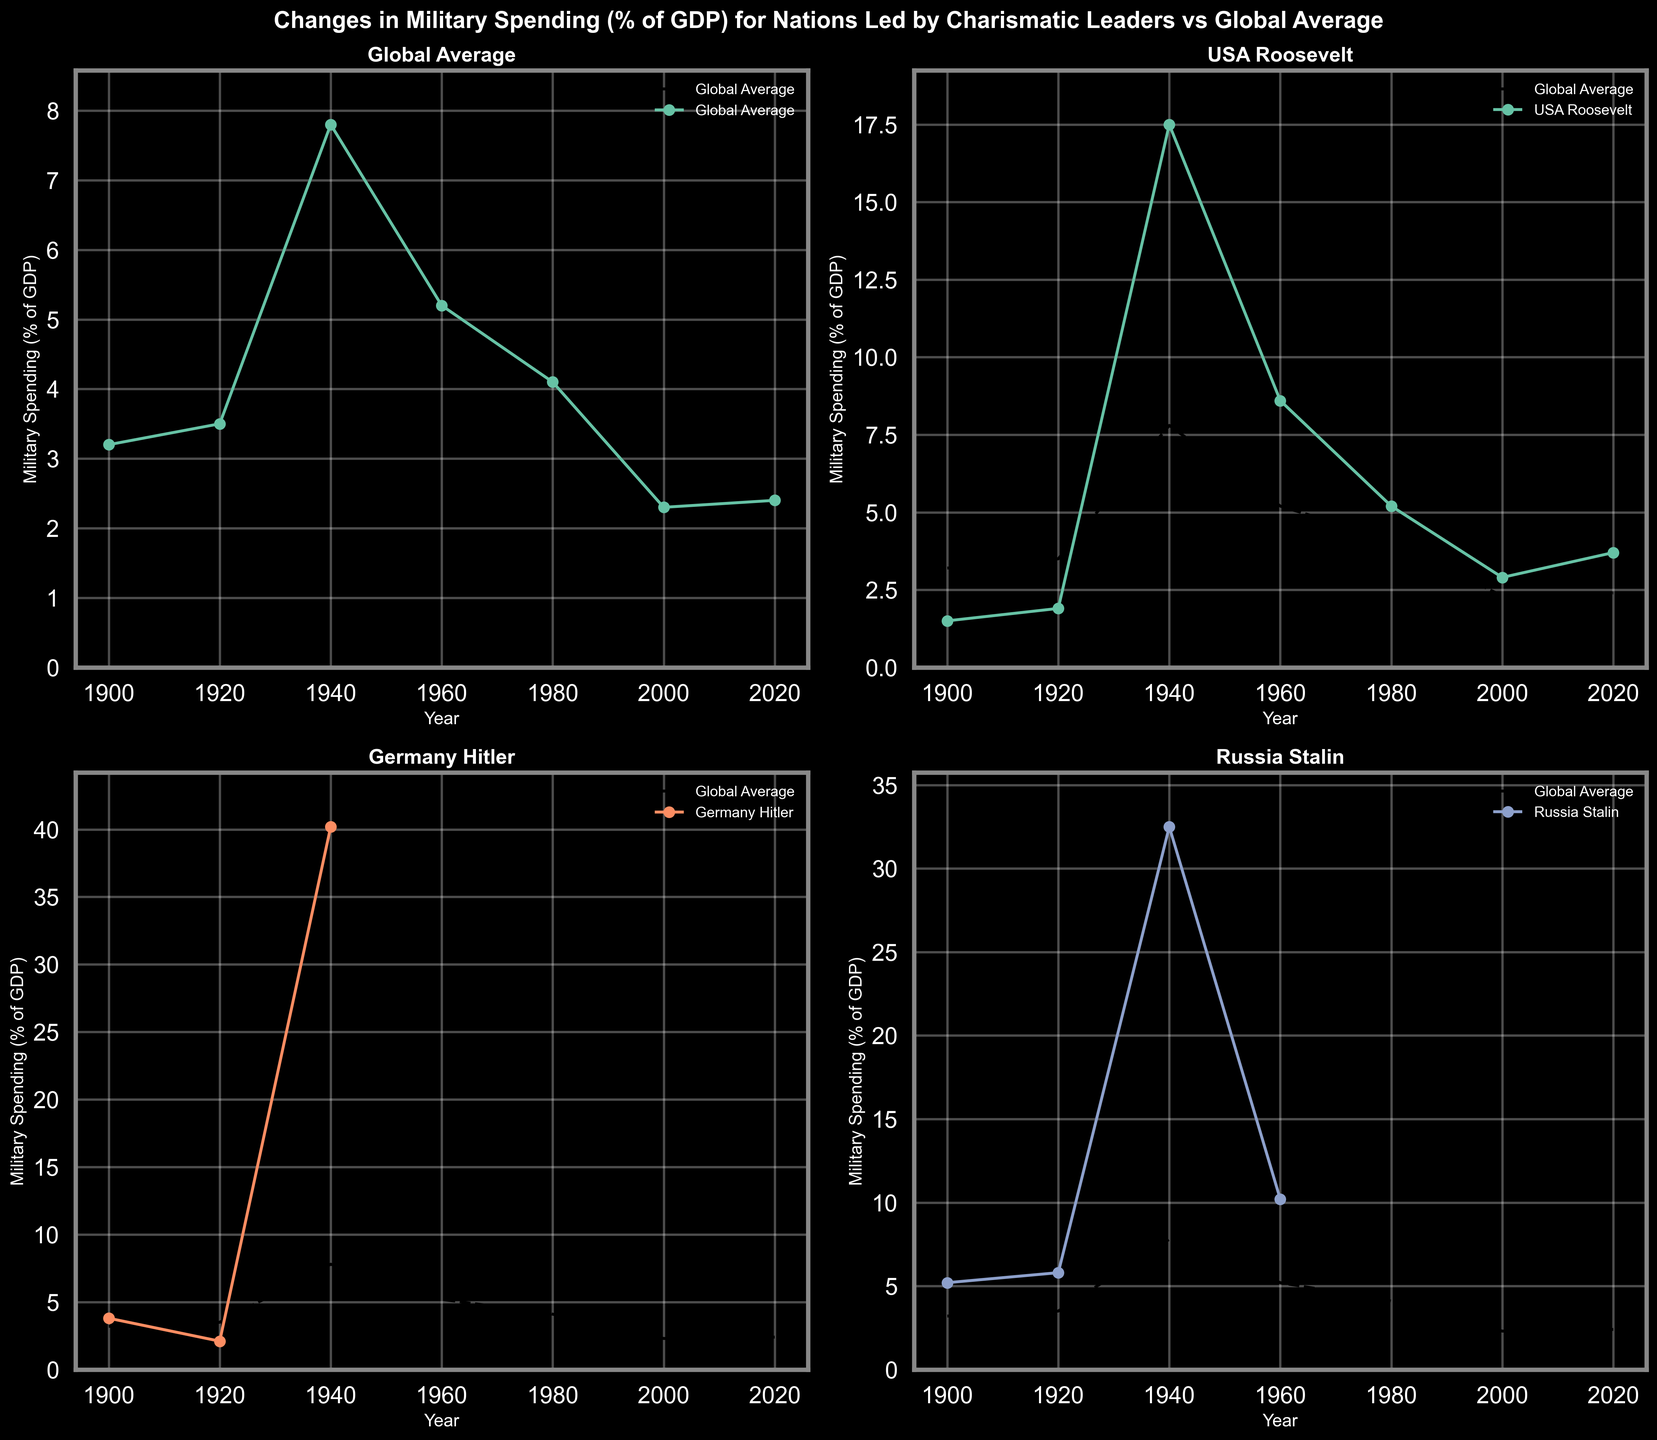What is the highest military spending as a percentage of GDP for Germany under Hitler? To answer this, look at the subplot for 'Germany Hitler' and find the peak value on the y-axis. In 1940, the percentage for Germany under Hitler is marked as 40.2%.
Answer: 40.2% Which leader's country had the highest military spending as a percentage of GDP in 1940? Compare the military spending percentages for all leaders in 1940. The subplots for USA (Roosevelt), Germany (Hitler), Russia (Stalin), and UK (Churchill) are relevant. UK (Churchill) shows the peak value of 52.7%.
Answer: UK (Churchill) How did the global average change from 1900 to 2020? Compare the values of the global average military spending percentage in 1900 and 2020. In 1900 it was 3.2% and in 2020 it was 2.4%. Therefore, it decreased by 0.8%.
Answer: Decreased by 0.8% Which leader shows the highest fluctuation in military spending? Look at the subplots and identify the leader whose line chart has the most significant ups and downs. Germany (Hitler) has a noticeable rise and drop, going from 3.8% in 1900 to 40.2% in 1940, then dropping sharply.
Answer: Germany (Hitler) Which countries under charismatic leaders had higher military spending than the global average in 1980? Compare the values in 1980 between the global average (4.1%) and those of USA (Roosevelt), USSR (Khrushchev), Cuba (Castro), and South Africa (Mandela). Only USA (Roosevelt) and USSR (Khrushchev) had 5.2% and 12.5% respectively.
Answer: USA (Roosevelt) and USSR (Khrushchev) By how much did military spending change from 1960 to 2000 for Russia under Stalin? First verify the existence of both data points. Data for Russia under Stalin is available for 1960 at 10.2%; there is no data for Russia Stalin in 2000, so this can’t be calculated.
Answer: Data not available Comparing USA under Reagan and Russia under Putin in 2020, which had higher military spending? Look at the 2020 values for USA (Reagan) and Russia (Putin). USA has 3.7%, while Russia has 4.3%. Therefore, Russia under Putin had higher spending.
Answer: Russia (Putin) What is the trend of military spending for Cuba under Castro during 1980 and 2000? Check the provided values in 1980 (9.5%) and 2000 (3.8%). The military spending decreased significantly over this period.
Answer: Decreased Which year saw the highest global average military spending as a percentage of GDP? Identify the peak value in the global average line across all years. The highest value observed is in 1940 at 7.8%.
Answer: 1940 